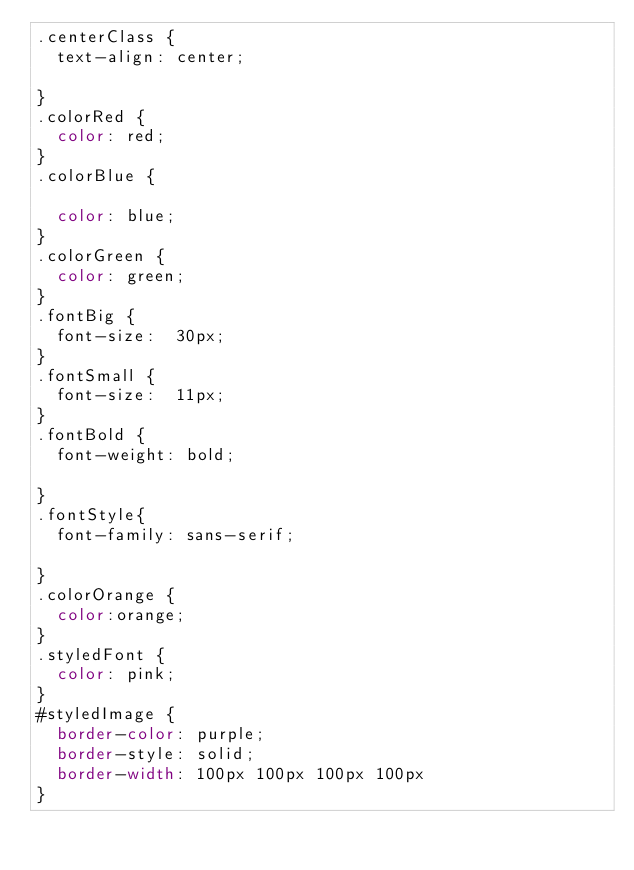<code> <loc_0><loc_0><loc_500><loc_500><_CSS_>.centerClass {
	text-align: center;

}
.colorRed {
	color: red;
}
.colorBlue {

	color: blue;
}
.colorGreen {
	color: green;
}
.fontBig {
	font-size:  30px;
}
.fontSmall {
	font-size:  11px;
}
.fontBold	{ 
	font-weight: bold;

}
.fontStyle{
	font-family: sans-serif;

}
.colorOrange {
 	color:orange;
}
.styledFont {
	color: pink;
}
#styledImage {
	border-color: purple;
	border-style: solid;
	border-width: 100px 100px 100px 100px 	
}
</code> 